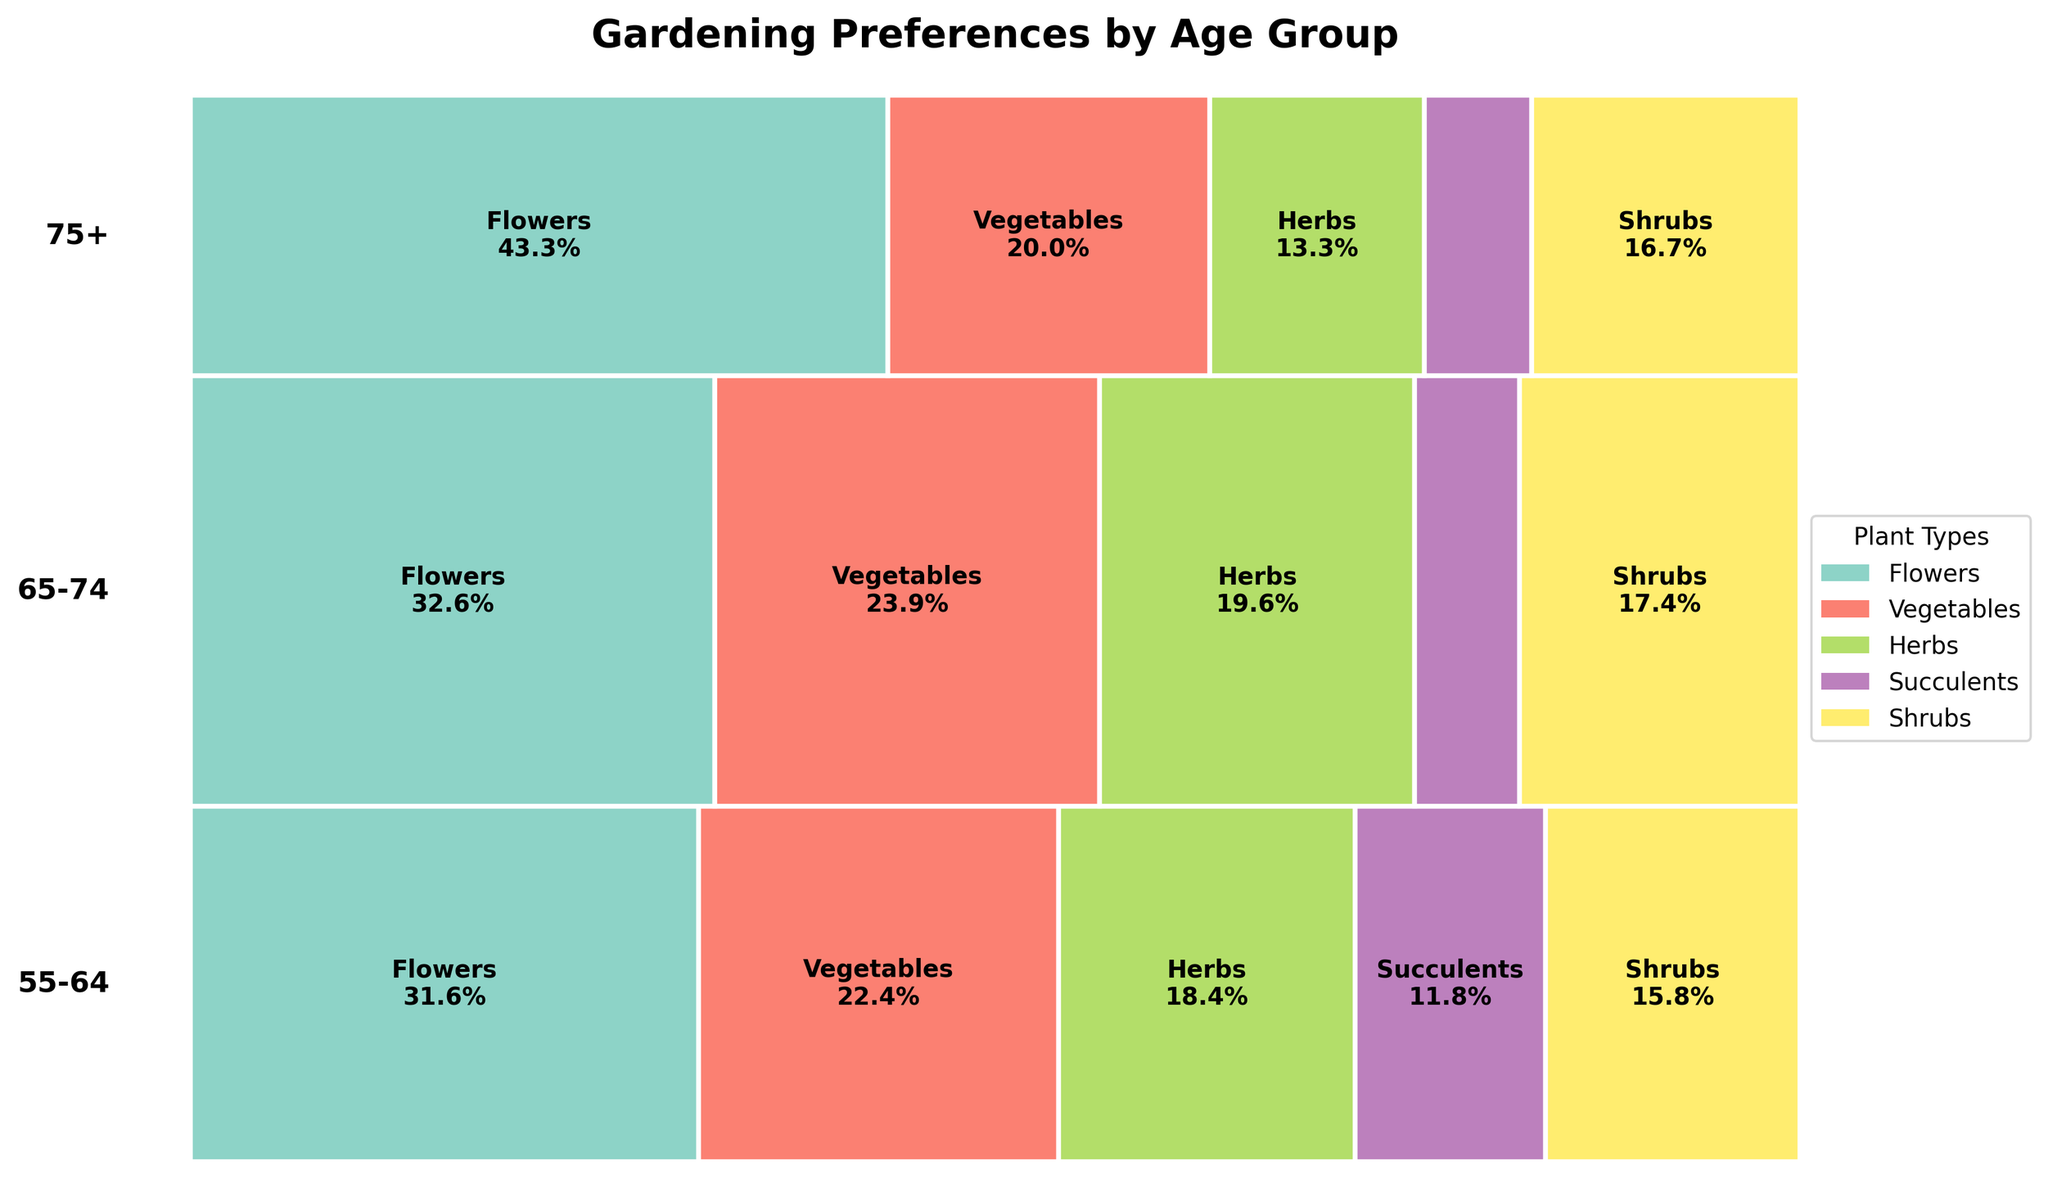What's the title of the plot? The title is located at the top of the plot. It is usually displayed in a prominent, bold font to indicate the main topic of the figure.
Answer: Gardening Preferences by Age Group Which age group shows the highest preference for Flowers? Look at the tallest rectangle associated with Flowers and check which age group it belongs to. The tallest rectangle associated with Flowers is in the 65-74 age group.
Answer: 65-74 Which Plant Type has the least preference in the 75+ age group? Look in the 75+ age group section and identify the smallest rectangle. Succulents have the smallest rectangle in this age group.
Answer: Succulents What is the proportion of Herbs preference in the 65-74 age group? Find the 'Herbs' segment in the 65-74 age group portion of the plot and look at the percentage labeled in that rectangle. This rectangle is labeled "Herbs 30.0%".
Answer: 30.0% How does the number of Shrubs preferred by the 75+ age group compare to the 55-64 group? Count the size of the Shrubs rectangles in the 75+ and 55-64 groups. The Shrubs rectangle is larger for the 55-64 group compared to the 75+ group.
Answer: 55-64 > 75+ Which age group has the smallest proportion of Vegetable preferences? Look at the proportion of Vegetable preferences in all the age groups and identify the smallest one. The 75+ age group has the smallest Vegetable preference proportion.
Answer: 75+ What is the combined preference percentage of Flowers and Shrubs in the 65-74 age group? Find the percentages of 'Flowers' and 'Shrubs' in the 65-74 age group and add them. Flowers (40.0%) + Shrubs (20.0%) = 60.0%.
Answer: 60.0% In the 55-64 age group, which Plant Type has greater preference: Herbs or Succulents? Compare the percentages of Herbs and Succulents in the 55-64 section. Herbs show a larger rectangle than Succulents in this age group.
Answer: Herbs What’s the sum of preference counts for Vegetables across all age groups? Add the counts for Vegetables across the 55-64 (85), 65-74 (110), and 75+ (60) age groups. 85 + 110 + 60 = 255.
Answer: 255 Is there any Plant Type that has a consistent decrease in preference with age? Compare the sizes of the rectangles for each Plant Type across all age groups. 'Succulents' shows a decrease from 55-64 (45) to 65-74 (30) to 75+ (20).
Answer: Succulents 